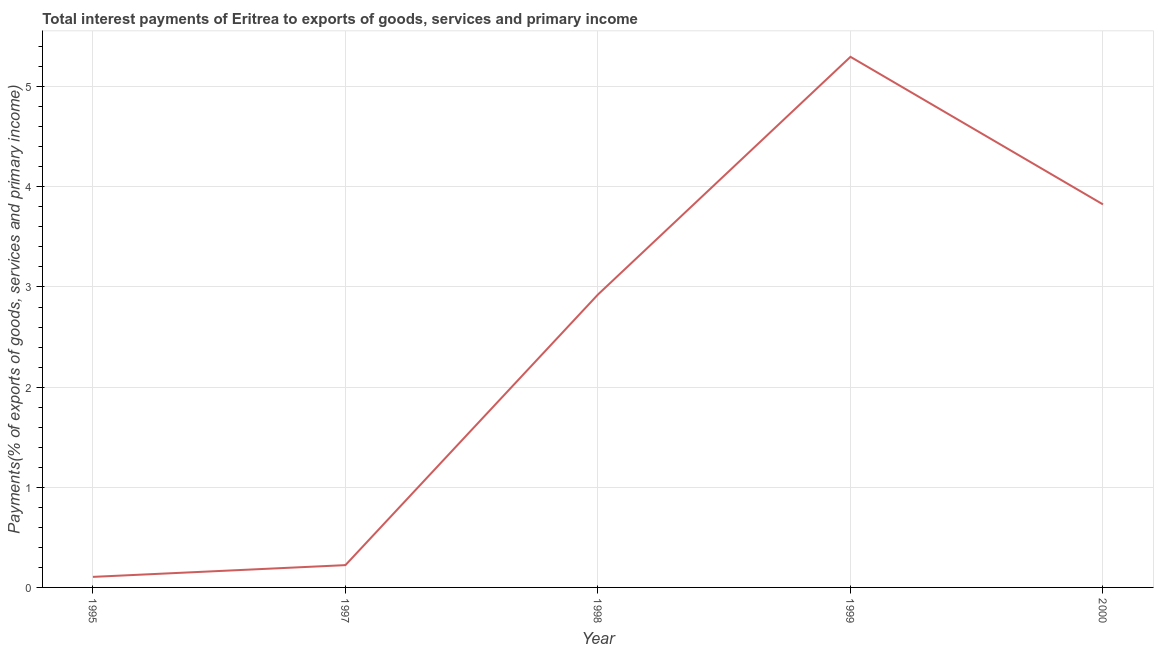What is the total interest payments on external debt in 2000?
Give a very brief answer. 3.82. Across all years, what is the maximum total interest payments on external debt?
Your answer should be compact. 5.3. Across all years, what is the minimum total interest payments on external debt?
Your answer should be compact. 0.11. What is the sum of the total interest payments on external debt?
Ensure brevity in your answer.  12.38. What is the difference between the total interest payments on external debt in 1998 and 2000?
Your answer should be compact. -0.9. What is the average total interest payments on external debt per year?
Give a very brief answer. 2.48. What is the median total interest payments on external debt?
Provide a short and direct response. 2.92. What is the ratio of the total interest payments on external debt in 1998 to that in 1999?
Your answer should be very brief. 0.55. What is the difference between the highest and the second highest total interest payments on external debt?
Provide a succinct answer. 1.47. What is the difference between the highest and the lowest total interest payments on external debt?
Your answer should be compact. 5.19. Does the total interest payments on external debt monotonically increase over the years?
Your answer should be compact. No. How many lines are there?
Ensure brevity in your answer.  1. What is the difference between two consecutive major ticks on the Y-axis?
Your response must be concise. 1. Are the values on the major ticks of Y-axis written in scientific E-notation?
Your answer should be very brief. No. What is the title of the graph?
Provide a short and direct response. Total interest payments of Eritrea to exports of goods, services and primary income. What is the label or title of the X-axis?
Offer a terse response. Year. What is the label or title of the Y-axis?
Keep it short and to the point. Payments(% of exports of goods, services and primary income). What is the Payments(% of exports of goods, services and primary income) in 1995?
Your response must be concise. 0.11. What is the Payments(% of exports of goods, services and primary income) of 1997?
Make the answer very short. 0.22. What is the Payments(% of exports of goods, services and primary income) of 1998?
Provide a succinct answer. 2.92. What is the Payments(% of exports of goods, services and primary income) of 1999?
Provide a succinct answer. 5.3. What is the Payments(% of exports of goods, services and primary income) in 2000?
Provide a succinct answer. 3.82. What is the difference between the Payments(% of exports of goods, services and primary income) in 1995 and 1997?
Give a very brief answer. -0.12. What is the difference between the Payments(% of exports of goods, services and primary income) in 1995 and 1998?
Offer a very short reply. -2.82. What is the difference between the Payments(% of exports of goods, services and primary income) in 1995 and 1999?
Your answer should be compact. -5.19. What is the difference between the Payments(% of exports of goods, services and primary income) in 1995 and 2000?
Keep it short and to the point. -3.72. What is the difference between the Payments(% of exports of goods, services and primary income) in 1997 and 1998?
Provide a succinct answer. -2.7. What is the difference between the Payments(% of exports of goods, services and primary income) in 1997 and 1999?
Keep it short and to the point. -5.08. What is the difference between the Payments(% of exports of goods, services and primary income) in 1997 and 2000?
Your answer should be very brief. -3.6. What is the difference between the Payments(% of exports of goods, services and primary income) in 1998 and 1999?
Give a very brief answer. -2.37. What is the difference between the Payments(% of exports of goods, services and primary income) in 1998 and 2000?
Make the answer very short. -0.9. What is the difference between the Payments(% of exports of goods, services and primary income) in 1999 and 2000?
Offer a terse response. 1.47. What is the ratio of the Payments(% of exports of goods, services and primary income) in 1995 to that in 1997?
Offer a terse response. 0.47. What is the ratio of the Payments(% of exports of goods, services and primary income) in 1995 to that in 1998?
Ensure brevity in your answer.  0.04. What is the ratio of the Payments(% of exports of goods, services and primary income) in 1995 to that in 2000?
Provide a short and direct response. 0.03. What is the ratio of the Payments(% of exports of goods, services and primary income) in 1997 to that in 1998?
Offer a terse response. 0.08. What is the ratio of the Payments(% of exports of goods, services and primary income) in 1997 to that in 1999?
Your answer should be very brief. 0.04. What is the ratio of the Payments(% of exports of goods, services and primary income) in 1997 to that in 2000?
Give a very brief answer. 0.06. What is the ratio of the Payments(% of exports of goods, services and primary income) in 1998 to that in 1999?
Offer a terse response. 0.55. What is the ratio of the Payments(% of exports of goods, services and primary income) in 1998 to that in 2000?
Offer a terse response. 0.77. What is the ratio of the Payments(% of exports of goods, services and primary income) in 1999 to that in 2000?
Offer a terse response. 1.39. 